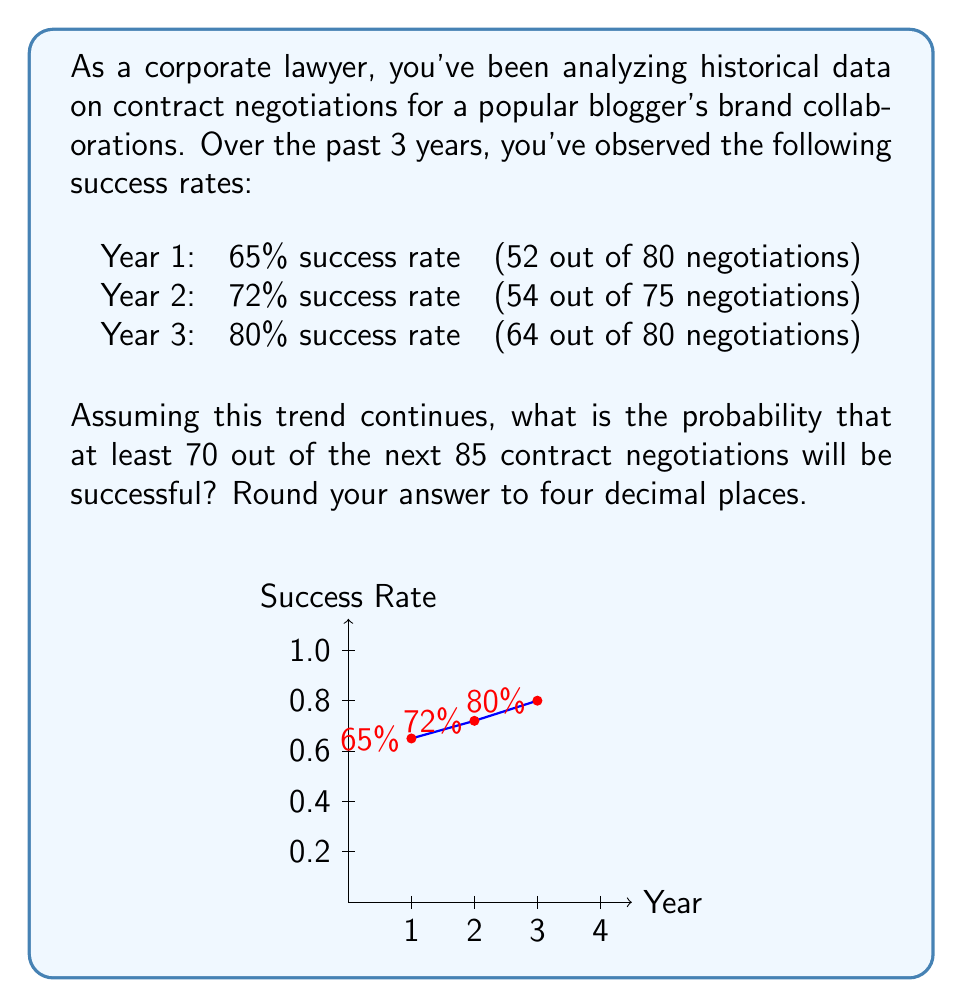Can you solve this math problem? To solve this problem, we'll follow these steps:

1) First, we need to estimate the probability of success for the next year based on the trend. We can see that the success rate is increasing linearly:

   Year 1 to 2: increase of 7%
   Year 2 to 3: increase of 8%

   Let's conservatively estimate the next year's success rate as 88% (80% + 8%).

2) Now, we can model this situation using a binomial distribution. We want the probability of at least 70 successes out of 85 trials, with each trial having a success probability of 0.88.

3) The probability of exactly $k$ successes in $n$ trials is given by the binomial probability formula:

   $$P(X = k) = \binom{n}{k} p^k (1-p)^{n-k}$$

   where $n = 85$, $p = 0.88$, and $k$ ranges from 70 to 85.

4) We need to sum this probability for all values of $k$ from 70 to 85:

   $$P(X \geq 70) = \sum_{k=70}^{85} \binom{85}{k} 0.88^k (1-0.88)^{85-k}$$

5) This sum is complicated to calculate by hand, so we would typically use statistical software or a calculator with a cumulative binomial probability function. Using such a tool, we get:

   $P(X \geq 70) \approx 0.9992$

6) Rounding to four decimal places, we get 0.9992.
Answer: 0.9992 